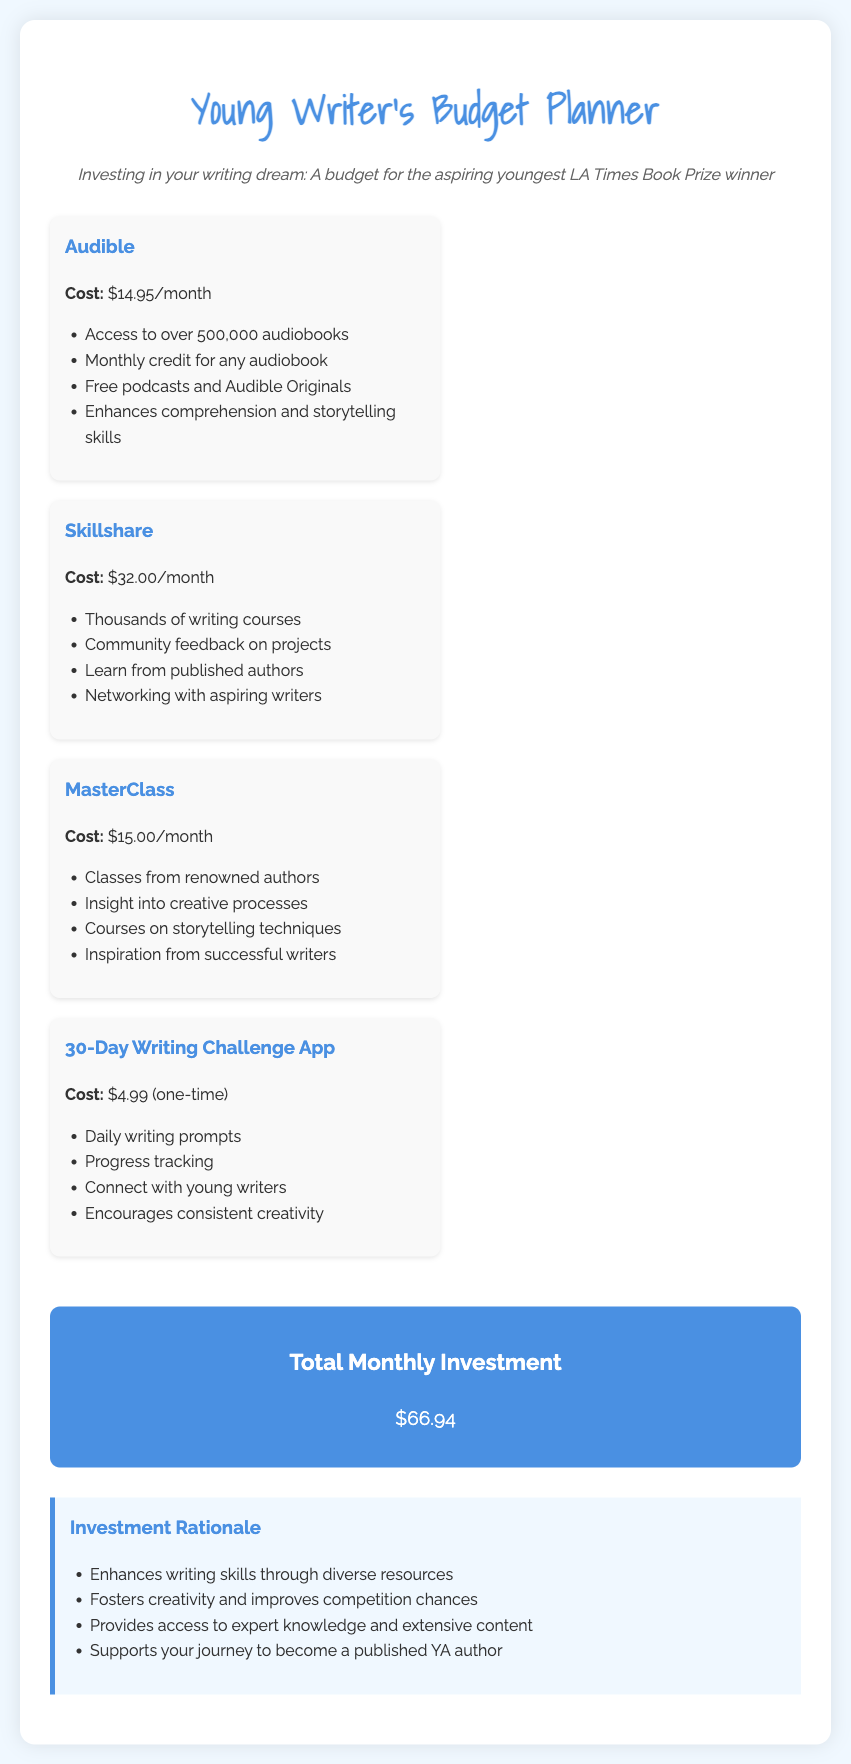What is the monthly cost of Audible? The monthly cost of Audible is stated in the document as $14.95.
Answer: $14.95 What features are included with Audible? The document lists the features of Audible, including access to over 500,000 audiobooks and free podcasts.
Answer: Over 500,000 audiobooks What is the total monthly investment? The total monthly investment is the sum of all subscription costs listed in the document, which totals $66.94.
Answer: $66.94 How much does Skillshare cost monthly? The monthly cost of Skillshare is mentioned as $32.00.
Answer: $32.00 What one-time cost is associated with the 30-Day Writing Challenge App? The document states that the one-time cost for the app is $4.99.
Answer: $4.99 Which subscription service provides access to renowned authors' classes? The document specifies that MasterClass provides access to courses from renowned authors.
Answer: MasterClass How does this budget support becoming a published YA author? The document mentions that the budget provides access to expert knowledge and extensive content, supporting the journey to publication.
Answer: Expert knowledge What is a benefit of using the Skillshare service? The document lists community feedback on projects as a benefit of Skillshare.
Answer: Community feedback What is one of the benefits of the 30-Day Writing Challenge App? The document states that the app offers daily writing prompts as a benefit.
Answer: Daily writing prompts 